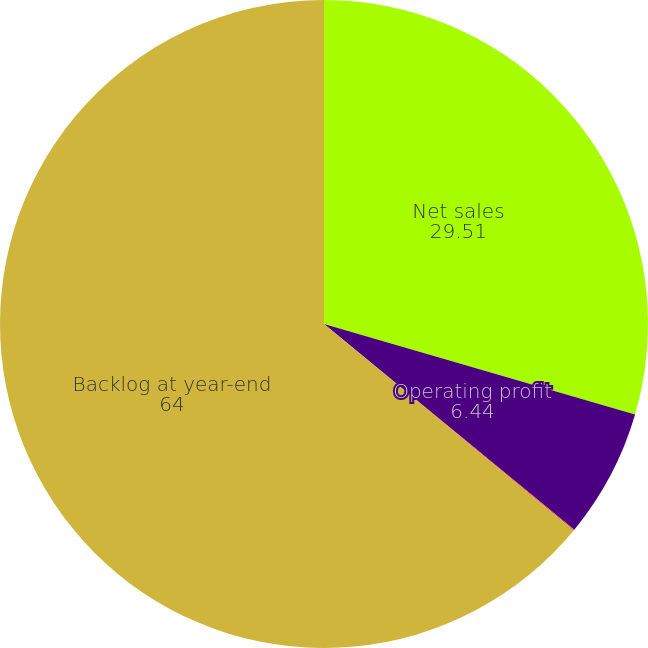<chart> <loc_0><loc_0><loc_500><loc_500><pie_chart><fcel>Net sales<fcel>Operating profit<fcel>Operating margins<fcel>Backlog at year-end<nl><fcel>29.51%<fcel>6.44%<fcel>0.05%<fcel>64.0%<nl></chart> 